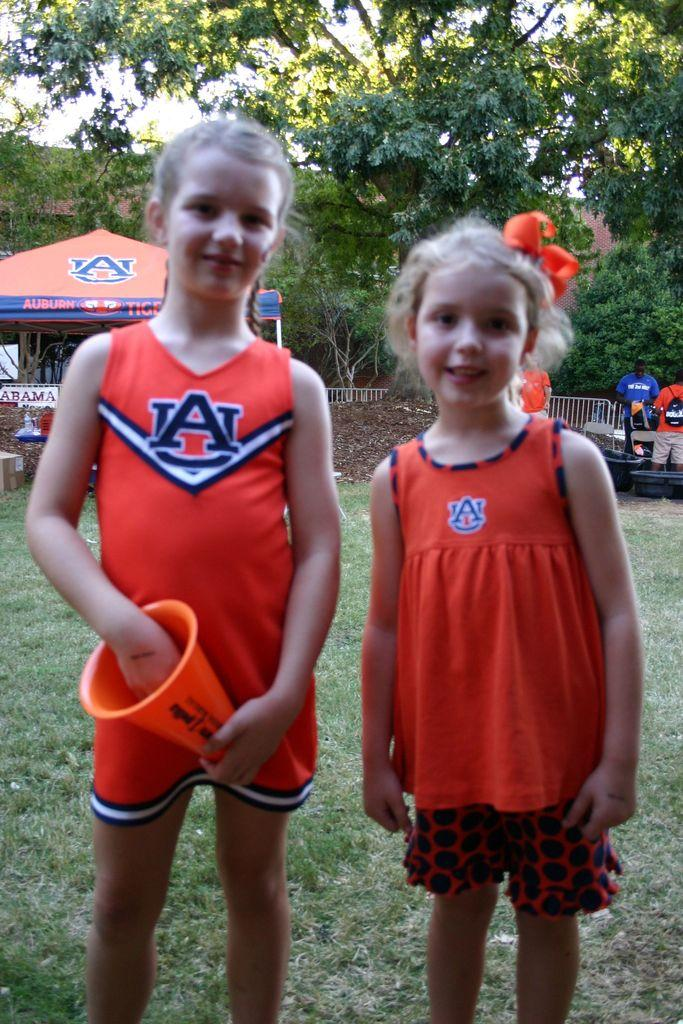<image>
Share a concise interpretation of the image provided. two small female cheerleaders in uniform for the auburn  tigers 